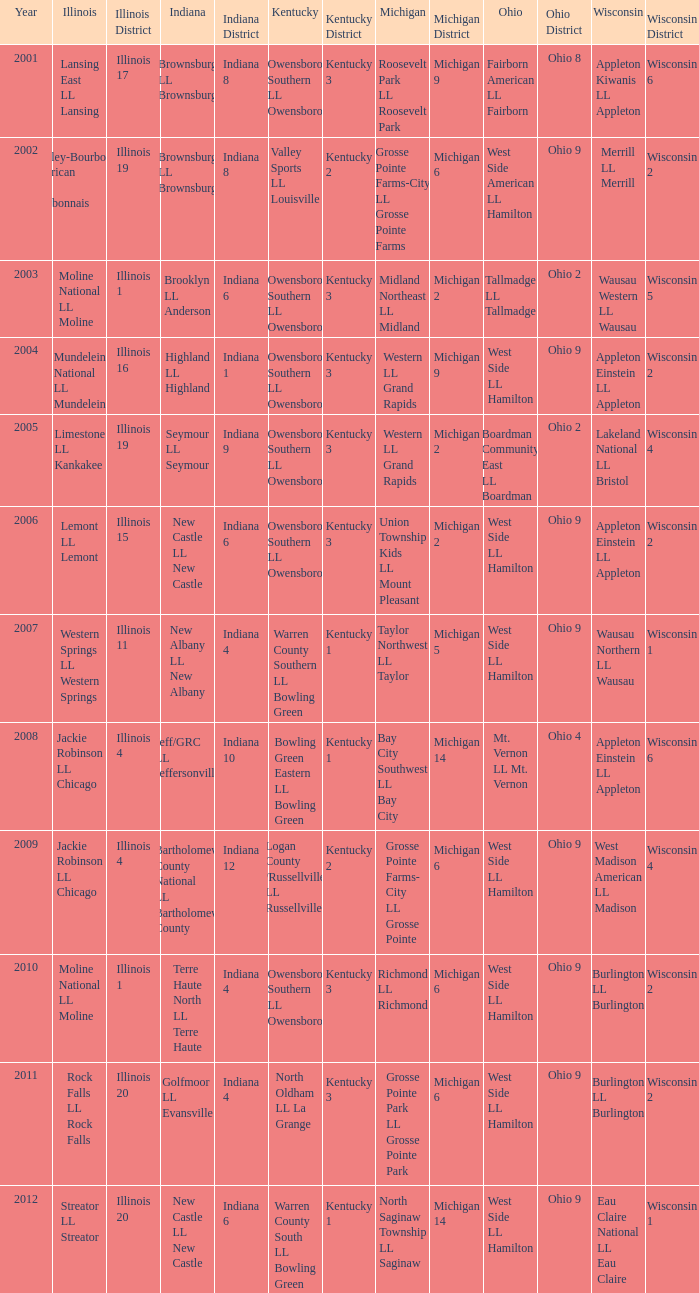What was the little league team from Ohio when the little league team from Kentucky was Warren County South LL Bowling Green? West Side LL Hamilton. 